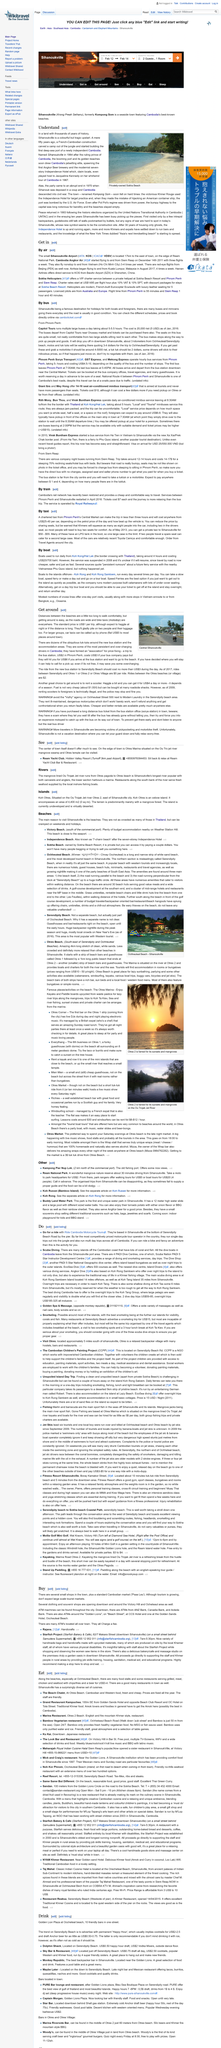List a handful of essential elements in this visual. The Independence Hotel in Sihanoukville, Cambodia has seven stories. The image was taken at Central Sihanoukville. Sihanoukville is home to a river known as Ou Trojak Jet, which is the longest river in the area. This river is an important source of water for the local community and provides a rich habitat for aquatic life. Jacqueline Kennedy visited Cambodia in 1967. The resumption of services between Phnom Penh and Sihanoukville occurred in 2016. 